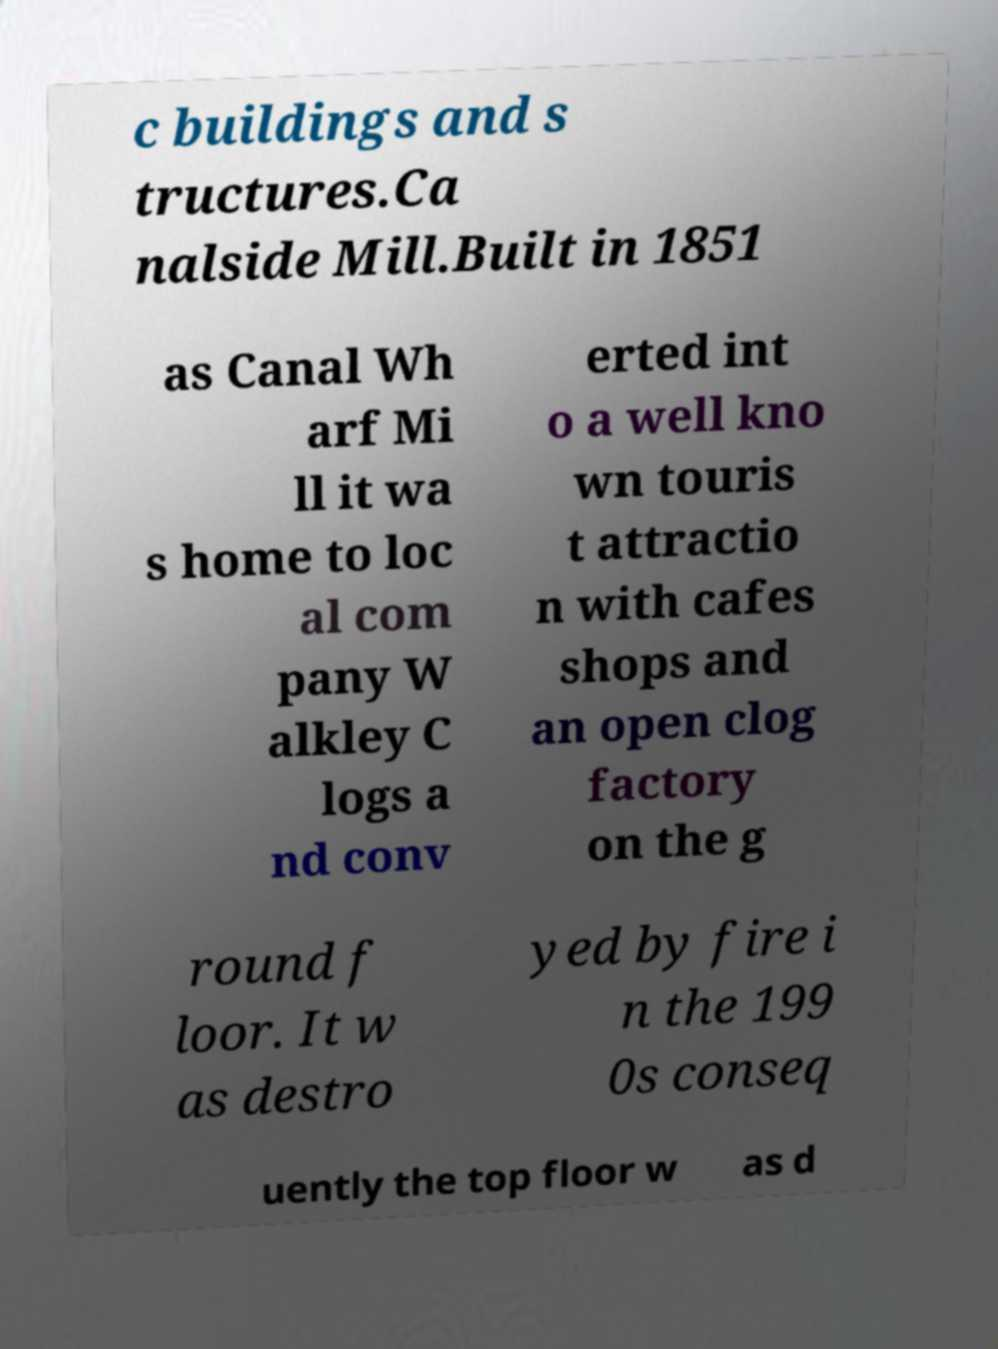There's text embedded in this image that I need extracted. Can you transcribe it verbatim? c buildings and s tructures.Ca nalside Mill.Built in 1851 as Canal Wh arf Mi ll it wa s home to loc al com pany W alkley C logs a nd conv erted int o a well kno wn touris t attractio n with cafes shops and an open clog factory on the g round f loor. It w as destro yed by fire i n the 199 0s conseq uently the top floor w as d 